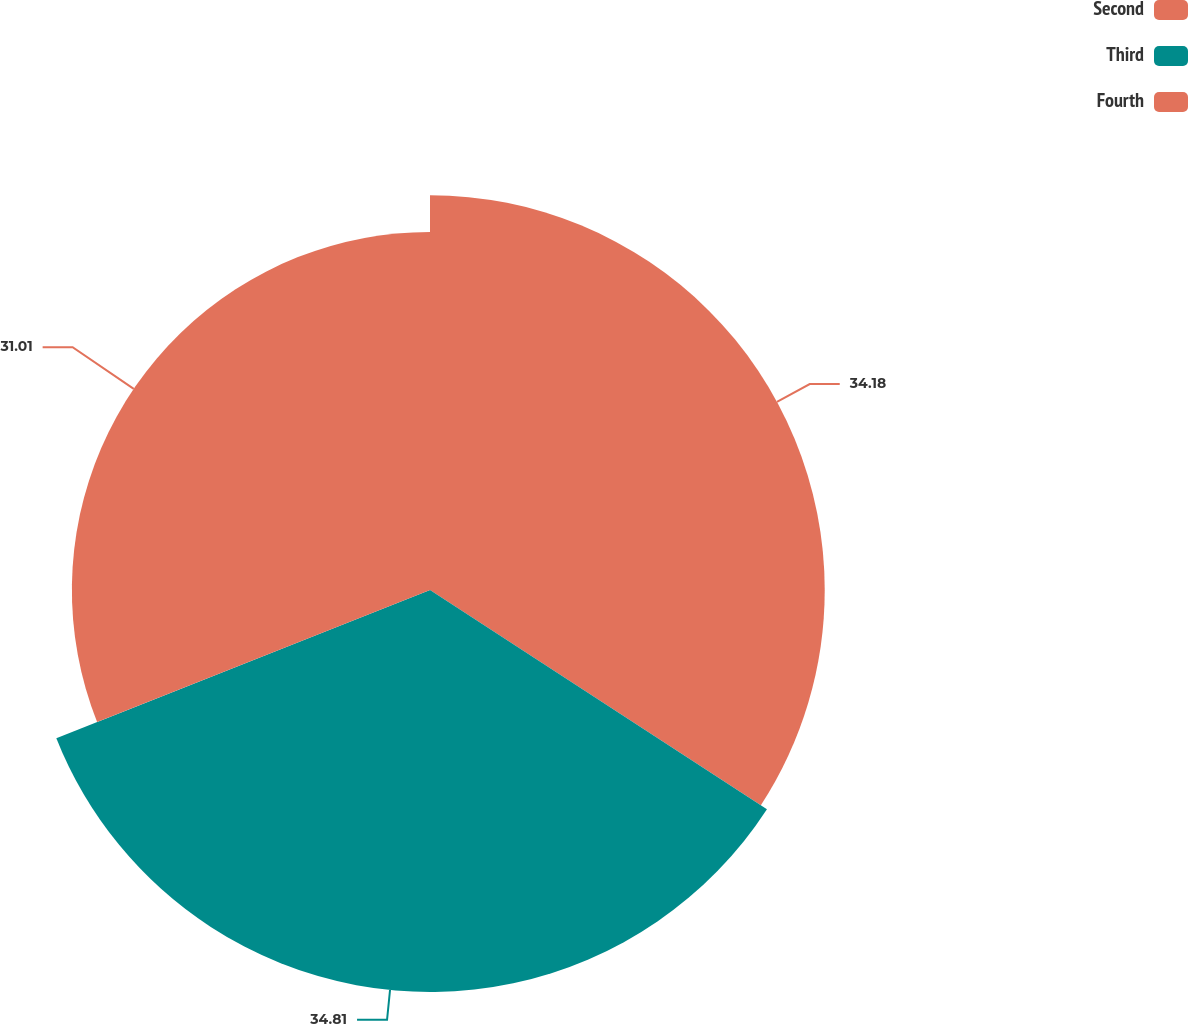<chart> <loc_0><loc_0><loc_500><loc_500><pie_chart><fcel>Second<fcel>Third<fcel>Fourth<nl><fcel>34.18%<fcel>34.81%<fcel>31.01%<nl></chart> 